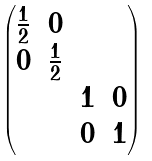Convert formula to latex. <formula><loc_0><loc_0><loc_500><loc_500>\begin{pmatrix} \frac { 1 } { 2 } & 0 & & \\ 0 & \frac { 1 } { 2 } & & \\ & & 1 & 0 \\ & & 0 & 1 \end{pmatrix}</formula> 